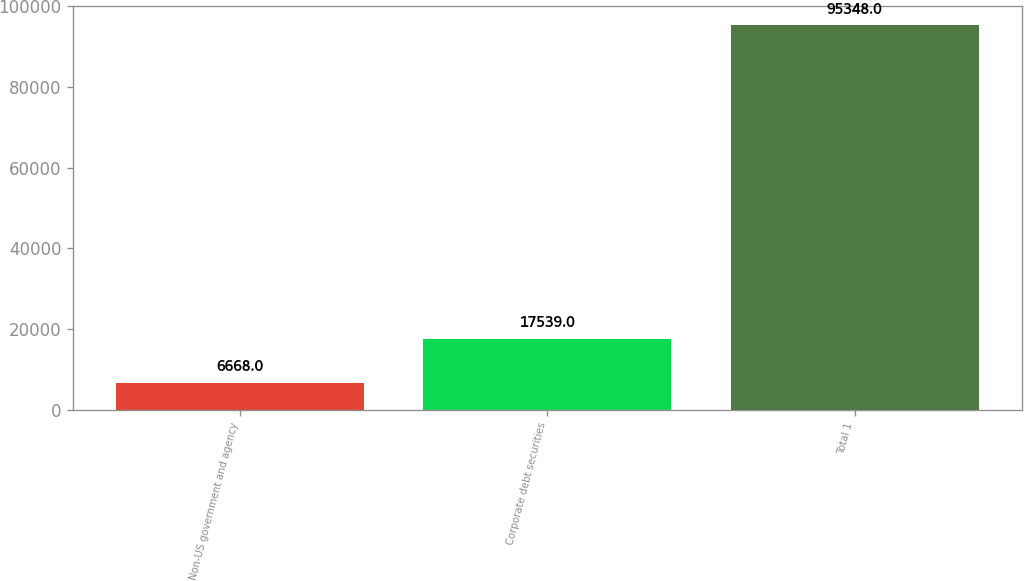Convert chart. <chart><loc_0><loc_0><loc_500><loc_500><bar_chart><fcel>Non-US government and agency<fcel>Corporate debt securities<fcel>Total 1<nl><fcel>6668<fcel>17539<fcel>95348<nl></chart> 